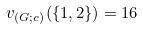Convert formula to latex. <formula><loc_0><loc_0><loc_500><loc_500>v _ { ( G ; c ) } ( \{ 1 , 2 \} ) = 1 6</formula> 